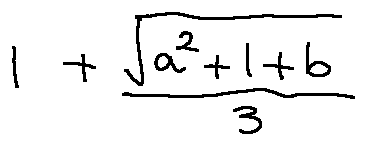<formula> <loc_0><loc_0><loc_500><loc_500>1 + \frac { \sqrt { a ^ { 2 } + 1 + b } } { 3 }</formula> 